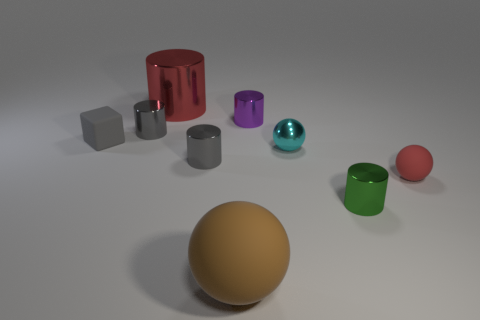Subtract all green cylinders. How many cylinders are left? 4 Subtract all red metal cylinders. How many cylinders are left? 4 Subtract all brown cylinders. Subtract all cyan balls. How many cylinders are left? 5 Add 1 large brown matte objects. How many objects exist? 10 Subtract all cylinders. How many objects are left? 4 Add 3 red shiny objects. How many red shiny objects are left? 4 Add 5 gray cylinders. How many gray cylinders exist? 7 Subtract 1 cyan balls. How many objects are left? 8 Subtract all metallic cylinders. Subtract all small brown shiny cylinders. How many objects are left? 4 